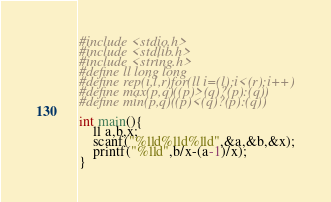<code> <loc_0><loc_0><loc_500><loc_500><_C_>#include <stdio.h>
#include <stdlib.h>
#include <string.h>
#define ll long long
#define rep(i,l,r)for(ll i=(l);i<(r);i++)
#define max(p,q)((p)>(q)?(p):(q))
#define min(p,q)((p)<(q)?(p):(q))

int main(){
	ll a,b,x;
	scanf("%lld%lld%lld",&a,&b,&x);
	printf("%lld",b/x-(a-1)/x);
}</code> 